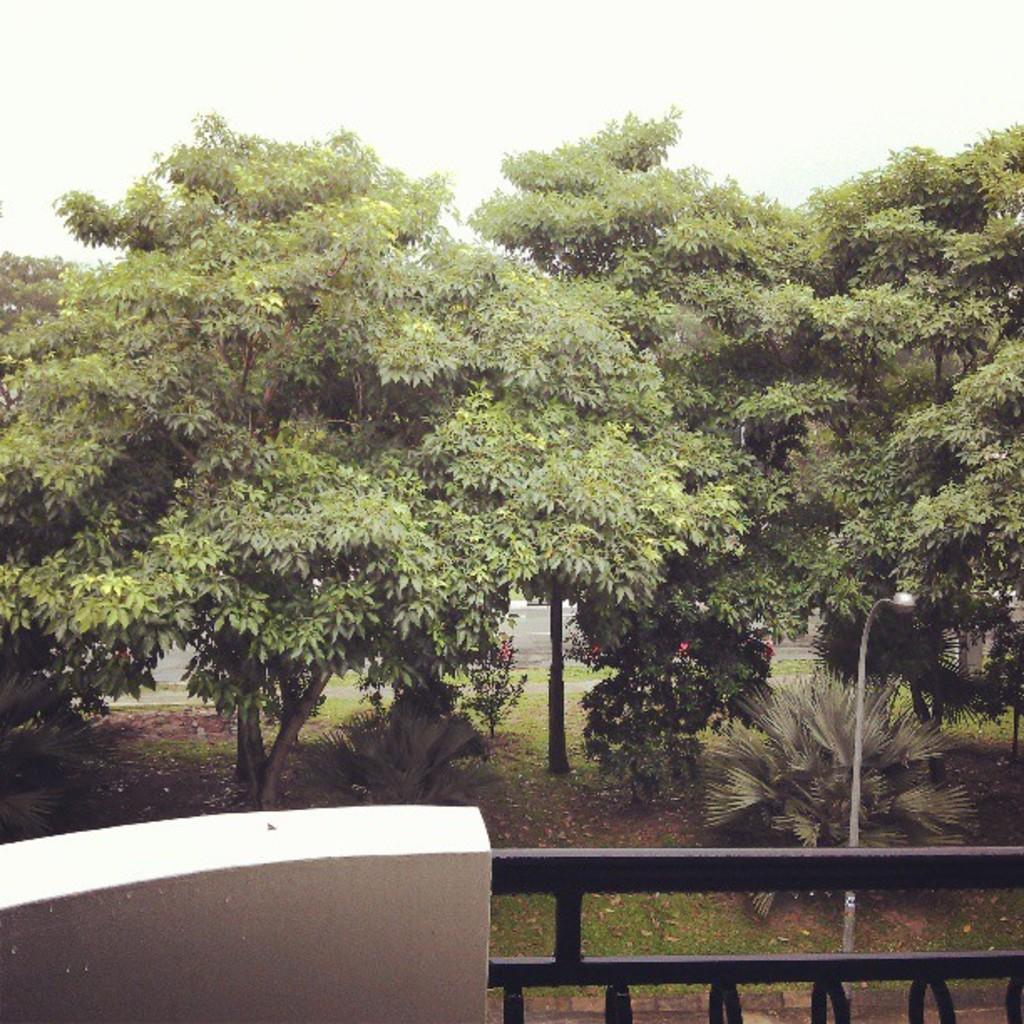Can you describe this image briefly? In this image we can see many trees. Also there is a light pole. At the bottom there is a railing. In the background there is sky. 